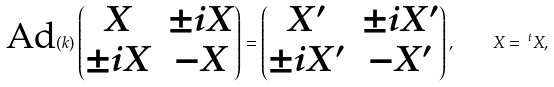<formula> <loc_0><loc_0><loc_500><loc_500>\text {Ad} ( k ) \begin{pmatrix} X & \pm i X \\ \pm i X & - X \end{pmatrix} = \begin{pmatrix} X ^ { \prime } & \pm i X ^ { \prime } \\ \pm i X ^ { \prime } & - X ^ { \prime } \end{pmatrix} , \quad X = \, ^ { t } X ,</formula> 